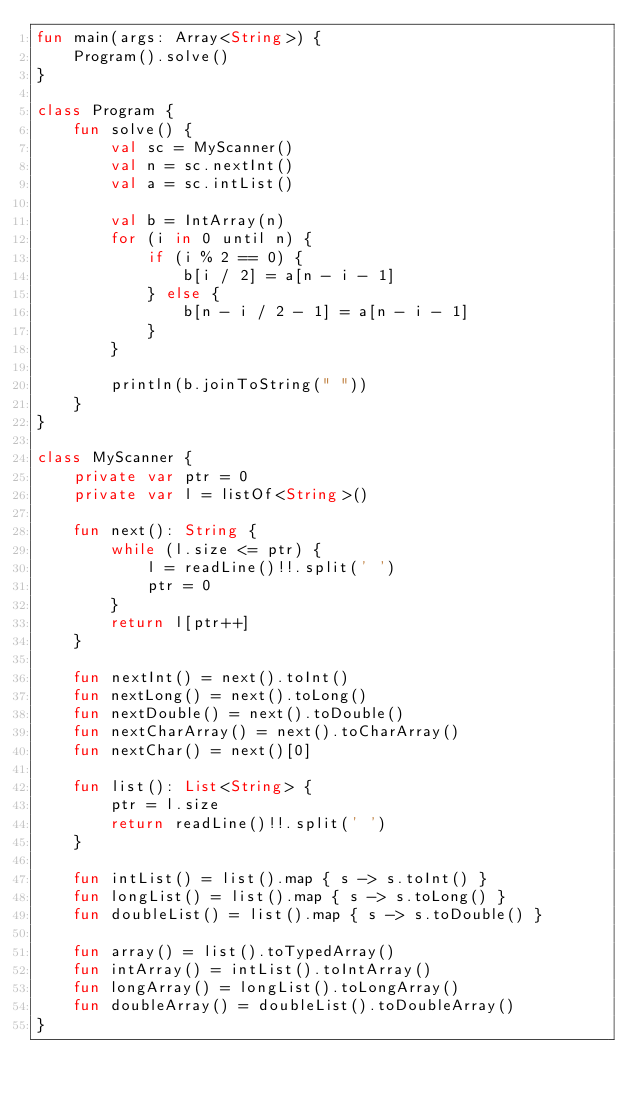<code> <loc_0><loc_0><loc_500><loc_500><_Kotlin_>fun main(args: Array<String>) {
    Program().solve()
}

class Program {
    fun solve() {
        val sc = MyScanner()
        val n = sc.nextInt()
        val a = sc.intList()

        val b = IntArray(n)
        for (i in 0 until n) {
            if (i % 2 == 0) {
                b[i / 2] = a[n - i - 1]
            } else {
                b[n - i / 2 - 1] = a[n - i - 1]
            }
        }

        println(b.joinToString(" "))
    }
}

class MyScanner {
    private var ptr = 0
    private var l = listOf<String>()

    fun next(): String {
        while (l.size <= ptr) {
            l = readLine()!!.split(' ')
            ptr = 0
        }
        return l[ptr++]
    }

    fun nextInt() = next().toInt()
    fun nextLong() = next().toLong()
    fun nextDouble() = next().toDouble()
    fun nextCharArray() = next().toCharArray()
    fun nextChar() = next()[0]

    fun list(): List<String> {
        ptr = l.size
        return readLine()!!.split(' ')
    }

    fun intList() = list().map { s -> s.toInt() }
    fun longList() = list().map { s -> s.toLong() }
    fun doubleList() = list().map { s -> s.toDouble() }

    fun array() = list().toTypedArray()
    fun intArray() = intList().toIntArray()
    fun longArray() = longList().toLongArray()
    fun doubleArray() = doubleList().toDoubleArray()
}
</code> 